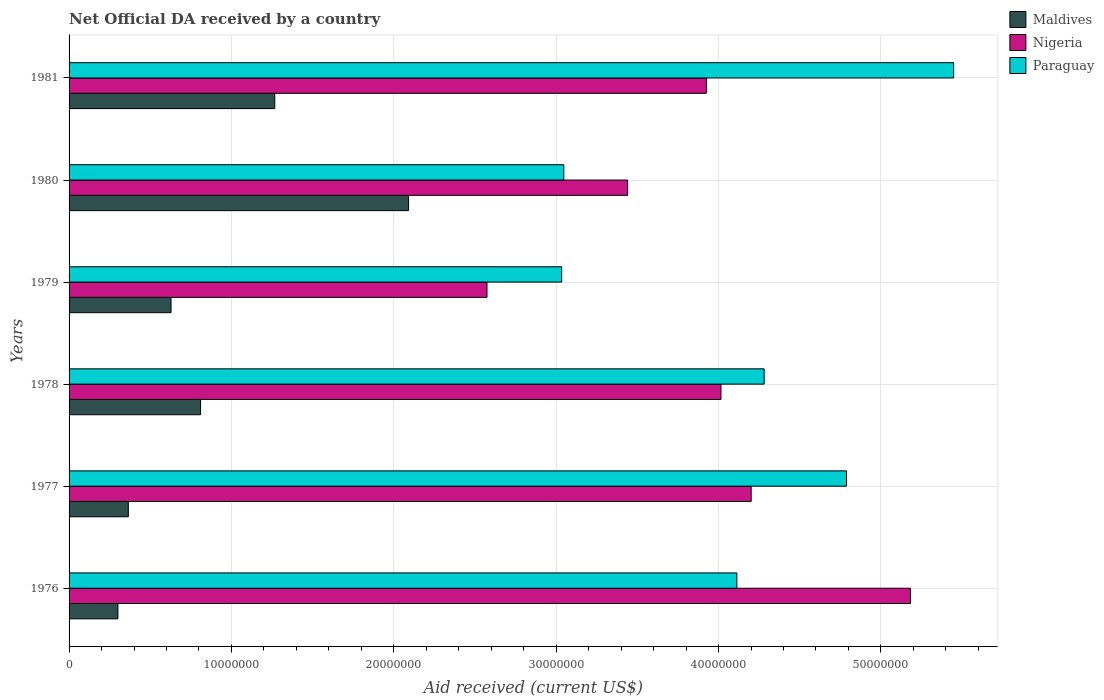How many groups of bars are there?
Ensure brevity in your answer.  6. Are the number of bars on each tick of the Y-axis equal?
Offer a very short reply. Yes. How many bars are there on the 1st tick from the top?
Keep it short and to the point. 3. How many bars are there on the 3rd tick from the bottom?
Keep it short and to the point. 3. What is the label of the 5th group of bars from the top?
Keep it short and to the point. 1977. What is the net official development assistance aid received in Paraguay in 1978?
Offer a terse response. 4.28e+07. Across all years, what is the maximum net official development assistance aid received in Maldives?
Offer a terse response. 2.09e+07. Across all years, what is the minimum net official development assistance aid received in Paraguay?
Provide a succinct answer. 3.03e+07. In which year was the net official development assistance aid received in Paraguay maximum?
Provide a short and direct response. 1981. In which year was the net official development assistance aid received in Maldives minimum?
Your answer should be compact. 1976. What is the total net official development assistance aid received in Maldives in the graph?
Your answer should be compact. 5.46e+07. What is the difference between the net official development assistance aid received in Paraguay in 1977 and that in 1978?
Offer a very short reply. 5.07e+06. What is the difference between the net official development assistance aid received in Maldives in 1978 and the net official development assistance aid received in Nigeria in 1976?
Give a very brief answer. -4.37e+07. What is the average net official development assistance aid received in Nigeria per year?
Provide a succinct answer. 3.89e+07. In the year 1976, what is the difference between the net official development assistance aid received in Maldives and net official development assistance aid received in Nigeria?
Provide a short and direct response. -4.88e+07. What is the ratio of the net official development assistance aid received in Paraguay in 1980 to that in 1981?
Give a very brief answer. 0.56. Is the net official development assistance aid received in Paraguay in 1977 less than that in 1979?
Your response must be concise. No. What is the difference between the highest and the second highest net official development assistance aid received in Paraguay?
Provide a short and direct response. 6.60e+06. What is the difference between the highest and the lowest net official development assistance aid received in Nigeria?
Ensure brevity in your answer.  2.61e+07. In how many years, is the net official development assistance aid received in Maldives greater than the average net official development assistance aid received in Maldives taken over all years?
Your response must be concise. 2. Is the sum of the net official development assistance aid received in Nigeria in 1976 and 1979 greater than the maximum net official development assistance aid received in Maldives across all years?
Provide a short and direct response. Yes. What does the 1st bar from the top in 1981 represents?
Offer a very short reply. Paraguay. What does the 2nd bar from the bottom in 1978 represents?
Ensure brevity in your answer.  Nigeria. Is it the case that in every year, the sum of the net official development assistance aid received in Paraguay and net official development assistance aid received in Maldives is greater than the net official development assistance aid received in Nigeria?
Offer a terse response. No. Are all the bars in the graph horizontal?
Give a very brief answer. Yes. How many years are there in the graph?
Give a very brief answer. 6. What is the difference between two consecutive major ticks on the X-axis?
Provide a short and direct response. 1.00e+07. Are the values on the major ticks of X-axis written in scientific E-notation?
Provide a short and direct response. No. Does the graph contain grids?
Your response must be concise. Yes. How many legend labels are there?
Ensure brevity in your answer.  3. How are the legend labels stacked?
Keep it short and to the point. Vertical. What is the title of the graph?
Provide a succinct answer. Net Official DA received by a country. What is the label or title of the X-axis?
Your answer should be compact. Aid received (current US$). What is the Aid received (current US$) of Maldives in 1976?
Your answer should be very brief. 3.01e+06. What is the Aid received (current US$) in Nigeria in 1976?
Make the answer very short. 5.18e+07. What is the Aid received (current US$) of Paraguay in 1976?
Offer a very short reply. 4.11e+07. What is the Aid received (current US$) in Maldives in 1977?
Offer a terse response. 3.65e+06. What is the Aid received (current US$) of Nigeria in 1977?
Your response must be concise. 4.20e+07. What is the Aid received (current US$) of Paraguay in 1977?
Offer a very short reply. 4.79e+07. What is the Aid received (current US$) of Maldives in 1978?
Your response must be concise. 8.10e+06. What is the Aid received (current US$) of Nigeria in 1978?
Make the answer very short. 4.02e+07. What is the Aid received (current US$) in Paraguay in 1978?
Your answer should be compact. 4.28e+07. What is the Aid received (current US$) in Maldives in 1979?
Keep it short and to the point. 6.28e+06. What is the Aid received (current US$) of Nigeria in 1979?
Provide a succinct answer. 2.57e+07. What is the Aid received (current US$) in Paraguay in 1979?
Keep it short and to the point. 3.03e+07. What is the Aid received (current US$) of Maldives in 1980?
Make the answer very short. 2.09e+07. What is the Aid received (current US$) of Nigeria in 1980?
Your response must be concise. 3.44e+07. What is the Aid received (current US$) in Paraguay in 1980?
Your answer should be compact. 3.05e+07. What is the Aid received (current US$) of Maldives in 1981?
Keep it short and to the point. 1.27e+07. What is the Aid received (current US$) of Nigeria in 1981?
Make the answer very short. 3.92e+07. What is the Aid received (current US$) of Paraguay in 1981?
Your response must be concise. 5.45e+07. Across all years, what is the maximum Aid received (current US$) in Maldives?
Ensure brevity in your answer.  2.09e+07. Across all years, what is the maximum Aid received (current US$) of Nigeria?
Provide a short and direct response. 5.18e+07. Across all years, what is the maximum Aid received (current US$) of Paraguay?
Give a very brief answer. 5.45e+07. Across all years, what is the minimum Aid received (current US$) in Maldives?
Provide a succinct answer. 3.01e+06. Across all years, what is the minimum Aid received (current US$) in Nigeria?
Offer a very short reply. 2.57e+07. Across all years, what is the minimum Aid received (current US$) in Paraguay?
Provide a short and direct response. 3.03e+07. What is the total Aid received (current US$) of Maldives in the graph?
Give a very brief answer. 5.46e+07. What is the total Aid received (current US$) in Nigeria in the graph?
Provide a succinct answer. 2.33e+08. What is the total Aid received (current US$) of Paraguay in the graph?
Your response must be concise. 2.47e+08. What is the difference between the Aid received (current US$) of Maldives in 1976 and that in 1977?
Offer a very short reply. -6.40e+05. What is the difference between the Aid received (current US$) of Nigeria in 1976 and that in 1977?
Offer a very short reply. 9.81e+06. What is the difference between the Aid received (current US$) in Paraguay in 1976 and that in 1977?
Your response must be concise. -6.75e+06. What is the difference between the Aid received (current US$) of Maldives in 1976 and that in 1978?
Your answer should be very brief. -5.09e+06. What is the difference between the Aid received (current US$) of Nigeria in 1976 and that in 1978?
Your response must be concise. 1.17e+07. What is the difference between the Aid received (current US$) of Paraguay in 1976 and that in 1978?
Ensure brevity in your answer.  -1.68e+06. What is the difference between the Aid received (current US$) in Maldives in 1976 and that in 1979?
Give a very brief answer. -3.27e+06. What is the difference between the Aid received (current US$) in Nigeria in 1976 and that in 1979?
Offer a terse response. 2.61e+07. What is the difference between the Aid received (current US$) in Paraguay in 1976 and that in 1979?
Give a very brief answer. 1.08e+07. What is the difference between the Aid received (current US$) of Maldives in 1976 and that in 1980?
Offer a very short reply. -1.79e+07. What is the difference between the Aid received (current US$) of Nigeria in 1976 and that in 1980?
Keep it short and to the point. 1.74e+07. What is the difference between the Aid received (current US$) of Paraguay in 1976 and that in 1980?
Provide a succinct answer. 1.07e+07. What is the difference between the Aid received (current US$) in Maldives in 1976 and that in 1981?
Give a very brief answer. -9.66e+06. What is the difference between the Aid received (current US$) of Nigeria in 1976 and that in 1981?
Give a very brief answer. 1.26e+07. What is the difference between the Aid received (current US$) in Paraguay in 1976 and that in 1981?
Keep it short and to the point. -1.34e+07. What is the difference between the Aid received (current US$) of Maldives in 1977 and that in 1978?
Provide a short and direct response. -4.45e+06. What is the difference between the Aid received (current US$) of Nigeria in 1977 and that in 1978?
Offer a terse response. 1.86e+06. What is the difference between the Aid received (current US$) of Paraguay in 1977 and that in 1978?
Provide a short and direct response. 5.07e+06. What is the difference between the Aid received (current US$) in Maldives in 1977 and that in 1979?
Your response must be concise. -2.63e+06. What is the difference between the Aid received (current US$) in Nigeria in 1977 and that in 1979?
Provide a short and direct response. 1.63e+07. What is the difference between the Aid received (current US$) of Paraguay in 1977 and that in 1979?
Ensure brevity in your answer.  1.75e+07. What is the difference between the Aid received (current US$) of Maldives in 1977 and that in 1980?
Give a very brief answer. -1.73e+07. What is the difference between the Aid received (current US$) in Nigeria in 1977 and that in 1980?
Your answer should be compact. 7.61e+06. What is the difference between the Aid received (current US$) of Paraguay in 1977 and that in 1980?
Give a very brief answer. 1.74e+07. What is the difference between the Aid received (current US$) of Maldives in 1977 and that in 1981?
Offer a very short reply. -9.02e+06. What is the difference between the Aid received (current US$) of Nigeria in 1977 and that in 1981?
Offer a very short reply. 2.76e+06. What is the difference between the Aid received (current US$) in Paraguay in 1977 and that in 1981?
Your answer should be very brief. -6.60e+06. What is the difference between the Aid received (current US$) of Maldives in 1978 and that in 1979?
Provide a short and direct response. 1.82e+06. What is the difference between the Aid received (current US$) of Nigeria in 1978 and that in 1979?
Your answer should be compact. 1.44e+07. What is the difference between the Aid received (current US$) of Paraguay in 1978 and that in 1979?
Offer a terse response. 1.25e+07. What is the difference between the Aid received (current US$) of Maldives in 1978 and that in 1980?
Provide a short and direct response. -1.28e+07. What is the difference between the Aid received (current US$) of Nigeria in 1978 and that in 1980?
Offer a terse response. 5.75e+06. What is the difference between the Aid received (current US$) of Paraguay in 1978 and that in 1980?
Keep it short and to the point. 1.23e+07. What is the difference between the Aid received (current US$) in Maldives in 1978 and that in 1981?
Make the answer very short. -4.57e+06. What is the difference between the Aid received (current US$) of Nigeria in 1978 and that in 1981?
Ensure brevity in your answer.  9.00e+05. What is the difference between the Aid received (current US$) of Paraguay in 1978 and that in 1981?
Keep it short and to the point. -1.17e+07. What is the difference between the Aid received (current US$) of Maldives in 1979 and that in 1980?
Offer a very short reply. -1.46e+07. What is the difference between the Aid received (current US$) in Nigeria in 1979 and that in 1980?
Offer a very short reply. -8.66e+06. What is the difference between the Aid received (current US$) in Maldives in 1979 and that in 1981?
Provide a succinct answer. -6.39e+06. What is the difference between the Aid received (current US$) of Nigeria in 1979 and that in 1981?
Ensure brevity in your answer.  -1.35e+07. What is the difference between the Aid received (current US$) of Paraguay in 1979 and that in 1981?
Provide a succinct answer. -2.41e+07. What is the difference between the Aid received (current US$) of Maldives in 1980 and that in 1981?
Make the answer very short. 8.24e+06. What is the difference between the Aid received (current US$) in Nigeria in 1980 and that in 1981?
Make the answer very short. -4.85e+06. What is the difference between the Aid received (current US$) of Paraguay in 1980 and that in 1981?
Keep it short and to the point. -2.40e+07. What is the difference between the Aid received (current US$) in Maldives in 1976 and the Aid received (current US$) in Nigeria in 1977?
Offer a terse response. -3.90e+07. What is the difference between the Aid received (current US$) in Maldives in 1976 and the Aid received (current US$) in Paraguay in 1977?
Keep it short and to the point. -4.49e+07. What is the difference between the Aid received (current US$) of Nigeria in 1976 and the Aid received (current US$) of Paraguay in 1977?
Give a very brief answer. 3.94e+06. What is the difference between the Aid received (current US$) in Maldives in 1976 and the Aid received (current US$) in Nigeria in 1978?
Your response must be concise. -3.71e+07. What is the difference between the Aid received (current US$) of Maldives in 1976 and the Aid received (current US$) of Paraguay in 1978?
Offer a very short reply. -3.98e+07. What is the difference between the Aid received (current US$) of Nigeria in 1976 and the Aid received (current US$) of Paraguay in 1978?
Keep it short and to the point. 9.01e+06. What is the difference between the Aid received (current US$) of Maldives in 1976 and the Aid received (current US$) of Nigeria in 1979?
Give a very brief answer. -2.27e+07. What is the difference between the Aid received (current US$) in Maldives in 1976 and the Aid received (current US$) in Paraguay in 1979?
Offer a very short reply. -2.73e+07. What is the difference between the Aid received (current US$) of Nigeria in 1976 and the Aid received (current US$) of Paraguay in 1979?
Provide a succinct answer. 2.15e+07. What is the difference between the Aid received (current US$) of Maldives in 1976 and the Aid received (current US$) of Nigeria in 1980?
Ensure brevity in your answer.  -3.14e+07. What is the difference between the Aid received (current US$) of Maldives in 1976 and the Aid received (current US$) of Paraguay in 1980?
Your response must be concise. -2.75e+07. What is the difference between the Aid received (current US$) in Nigeria in 1976 and the Aid received (current US$) in Paraguay in 1980?
Ensure brevity in your answer.  2.14e+07. What is the difference between the Aid received (current US$) of Maldives in 1976 and the Aid received (current US$) of Nigeria in 1981?
Your response must be concise. -3.62e+07. What is the difference between the Aid received (current US$) of Maldives in 1976 and the Aid received (current US$) of Paraguay in 1981?
Keep it short and to the point. -5.15e+07. What is the difference between the Aid received (current US$) of Nigeria in 1976 and the Aid received (current US$) of Paraguay in 1981?
Your response must be concise. -2.66e+06. What is the difference between the Aid received (current US$) of Maldives in 1977 and the Aid received (current US$) of Nigeria in 1978?
Give a very brief answer. -3.65e+07. What is the difference between the Aid received (current US$) of Maldives in 1977 and the Aid received (current US$) of Paraguay in 1978?
Your answer should be very brief. -3.92e+07. What is the difference between the Aid received (current US$) of Nigeria in 1977 and the Aid received (current US$) of Paraguay in 1978?
Your answer should be very brief. -8.00e+05. What is the difference between the Aid received (current US$) of Maldives in 1977 and the Aid received (current US$) of Nigeria in 1979?
Keep it short and to the point. -2.21e+07. What is the difference between the Aid received (current US$) of Maldives in 1977 and the Aid received (current US$) of Paraguay in 1979?
Offer a terse response. -2.67e+07. What is the difference between the Aid received (current US$) in Nigeria in 1977 and the Aid received (current US$) in Paraguay in 1979?
Ensure brevity in your answer.  1.17e+07. What is the difference between the Aid received (current US$) of Maldives in 1977 and the Aid received (current US$) of Nigeria in 1980?
Offer a terse response. -3.08e+07. What is the difference between the Aid received (current US$) of Maldives in 1977 and the Aid received (current US$) of Paraguay in 1980?
Offer a terse response. -2.68e+07. What is the difference between the Aid received (current US$) in Nigeria in 1977 and the Aid received (current US$) in Paraguay in 1980?
Provide a succinct answer. 1.15e+07. What is the difference between the Aid received (current US$) in Maldives in 1977 and the Aid received (current US$) in Nigeria in 1981?
Your answer should be compact. -3.56e+07. What is the difference between the Aid received (current US$) of Maldives in 1977 and the Aid received (current US$) of Paraguay in 1981?
Keep it short and to the point. -5.08e+07. What is the difference between the Aid received (current US$) in Nigeria in 1977 and the Aid received (current US$) in Paraguay in 1981?
Make the answer very short. -1.25e+07. What is the difference between the Aid received (current US$) of Maldives in 1978 and the Aid received (current US$) of Nigeria in 1979?
Keep it short and to the point. -1.76e+07. What is the difference between the Aid received (current US$) of Maldives in 1978 and the Aid received (current US$) of Paraguay in 1979?
Offer a very short reply. -2.22e+07. What is the difference between the Aid received (current US$) of Nigeria in 1978 and the Aid received (current US$) of Paraguay in 1979?
Provide a succinct answer. 9.81e+06. What is the difference between the Aid received (current US$) in Maldives in 1978 and the Aid received (current US$) in Nigeria in 1980?
Ensure brevity in your answer.  -2.63e+07. What is the difference between the Aid received (current US$) of Maldives in 1978 and the Aid received (current US$) of Paraguay in 1980?
Give a very brief answer. -2.24e+07. What is the difference between the Aid received (current US$) of Nigeria in 1978 and the Aid received (current US$) of Paraguay in 1980?
Offer a very short reply. 9.68e+06. What is the difference between the Aid received (current US$) of Maldives in 1978 and the Aid received (current US$) of Nigeria in 1981?
Ensure brevity in your answer.  -3.12e+07. What is the difference between the Aid received (current US$) in Maldives in 1978 and the Aid received (current US$) in Paraguay in 1981?
Ensure brevity in your answer.  -4.64e+07. What is the difference between the Aid received (current US$) in Nigeria in 1978 and the Aid received (current US$) in Paraguay in 1981?
Keep it short and to the point. -1.43e+07. What is the difference between the Aid received (current US$) of Maldives in 1979 and the Aid received (current US$) of Nigeria in 1980?
Provide a short and direct response. -2.81e+07. What is the difference between the Aid received (current US$) of Maldives in 1979 and the Aid received (current US$) of Paraguay in 1980?
Keep it short and to the point. -2.42e+07. What is the difference between the Aid received (current US$) in Nigeria in 1979 and the Aid received (current US$) in Paraguay in 1980?
Offer a terse response. -4.73e+06. What is the difference between the Aid received (current US$) of Maldives in 1979 and the Aid received (current US$) of Nigeria in 1981?
Provide a succinct answer. -3.30e+07. What is the difference between the Aid received (current US$) of Maldives in 1979 and the Aid received (current US$) of Paraguay in 1981?
Offer a terse response. -4.82e+07. What is the difference between the Aid received (current US$) in Nigeria in 1979 and the Aid received (current US$) in Paraguay in 1981?
Offer a very short reply. -2.87e+07. What is the difference between the Aid received (current US$) in Maldives in 1980 and the Aid received (current US$) in Nigeria in 1981?
Your answer should be compact. -1.83e+07. What is the difference between the Aid received (current US$) of Maldives in 1980 and the Aid received (current US$) of Paraguay in 1981?
Your response must be concise. -3.36e+07. What is the difference between the Aid received (current US$) of Nigeria in 1980 and the Aid received (current US$) of Paraguay in 1981?
Make the answer very short. -2.01e+07. What is the average Aid received (current US$) of Maldives per year?
Ensure brevity in your answer.  9.10e+06. What is the average Aid received (current US$) in Nigeria per year?
Make the answer very short. 3.89e+07. What is the average Aid received (current US$) in Paraguay per year?
Your answer should be very brief. 4.12e+07. In the year 1976, what is the difference between the Aid received (current US$) in Maldives and Aid received (current US$) in Nigeria?
Your response must be concise. -4.88e+07. In the year 1976, what is the difference between the Aid received (current US$) of Maldives and Aid received (current US$) of Paraguay?
Your answer should be very brief. -3.81e+07. In the year 1976, what is the difference between the Aid received (current US$) of Nigeria and Aid received (current US$) of Paraguay?
Make the answer very short. 1.07e+07. In the year 1977, what is the difference between the Aid received (current US$) of Maldives and Aid received (current US$) of Nigeria?
Provide a short and direct response. -3.84e+07. In the year 1977, what is the difference between the Aid received (current US$) of Maldives and Aid received (current US$) of Paraguay?
Provide a short and direct response. -4.42e+07. In the year 1977, what is the difference between the Aid received (current US$) of Nigeria and Aid received (current US$) of Paraguay?
Offer a terse response. -5.87e+06. In the year 1978, what is the difference between the Aid received (current US$) in Maldives and Aid received (current US$) in Nigeria?
Your response must be concise. -3.20e+07. In the year 1978, what is the difference between the Aid received (current US$) in Maldives and Aid received (current US$) in Paraguay?
Keep it short and to the point. -3.47e+07. In the year 1978, what is the difference between the Aid received (current US$) in Nigeria and Aid received (current US$) in Paraguay?
Offer a very short reply. -2.66e+06. In the year 1979, what is the difference between the Aid received (current US$) of Maldives and Aid received (current US$) of Nigeria?
Offer a very short reply. -1.95e+07. In the year 1979, what is the difference between the Aid received (current US$) of Maldives and Aid received (current US$) of Paraguay?
Provide a succinct answer. -2.41e+07. In the year 1979, what is the difference between the Aid received (current US$) of Nigeria and Aid received (current US$) of Paraguay?
Your response must be concise. -4.60e+06. In the year 1980, what is the difference between the Aid received (current US$) in Maldives and Aid received (current US$) in Nigeria?
Your response must be concise. -1.35e+07. In the year 1980, what is the difference between the Aid received (current US$) in Maldives and Aid received (current US$) in Paraguay?
Your answer should be very brief. -9.56e+06. In the year 1980, what is the difference between the Aid received (current US$) of Nigeria and Aid received (current US$) of Paraguay?
Provide a short and direct response. 3.93e+06. In the year 1981, what is the difference between the Aid received (current US$) in Maldives and Aid received (current US$) in Nigeria?
Offer a terse response. -2.66e+07. In the year 1981, what is the difference between the Aid received (current US$) of Maldives and Aid received (current US$) of Paraguay?
Your answer should be very brief. -4.18e+07. In the year 1981, what is the difference between the Aid received (current US$) of Nigeria and Aid received (current US$) of Paraguay?
Your answer should be very brief. -1.52e+07. What is the ratio of the Aid received (current US$) in Maldives in 1976 to that in 1977?
Offer a very short reply. 0.82. What is the ratio of the Aid received (current US$) of Nigeria in 1976 to that in 1977?
Your answer should be compact. 1.23. What is the ratio of the Aid received (current US$) of Paraguay in 1976 to that in 1977?
Provide a succinct answer. 0.86. What is the ratio of the Aid received (current US$) in Maldives in 1976 to that in 1978?
Give a very brief answer. 0.37. What is the ratio of the Aid received (current US$) in Nigeria in 1976 to that in 1978?
Ensure brevity in your answer.  1.29. What is the ratio of the Aid received (current US$) in Paraguay in 1976 to that in 1978?
Offer a very short reply. 0.96. What is the ratio of the Aid received (current US$) in Maldives in 1976 to that in 1979?
Offer a terse response. 0.48. What is the ratio of the Aid received (current US$) of Nigeria in 1976 to that in 1979?
Your answer should be very brief. 2.01. What is the ratio of the Aid received (current US$) in Paraguay in 1976 to that in 1979?
Give a very brief answer. 1.36. What is the ratio of the Aid received (current US$) in Maldives in 1976 to that in 1980?
Provide a succinct answer. 0.14. What is the ratio of the Aid received (current US$) of Nigeria in 1976 to that in 1980?
Your answer should be very brief. 1.51. What is the ratio of the Aid received (current US$) in Paraguay in 1976 to that in 1980?
Give a very brief answer. 1.35. What is the ratio of the Aid received (current US$) of Maldives in 1976 to that in 1981?
Ensure brevity in your answer.  0.24. What is the ratio of the Aid received (current US$) of Nigeria in 1976 to that in 1981?
Your answer should be very brief. 1.32. What is the ratio of the Aid received (current US$) of Paraguay in 1976 to that in 1981?
Ensure brevity in your answer.  0.76. What is the ratio of the Aid received (current US$) in Maldives in 1977 to that in 1978?
Provide a succinct answer. 0.45. What is the ratio of the Aid received (current US$) in Nigeria in 1977 to that in 1978?
Provide a short and direct response. 1.05. What is the ratio of the Aid received (current US$) of Paraguay in 1977 to that in 1978?
Offer a very short reply. 1.12. What is the ratio of the Aid received (current US$) of Maldives in 1977 to that in 1979?
Ensure brevity in your answer.  0.58. What is the ratio of the Aid received (current US$) in Nigeria in 1977 to that in 1979?
Ensure brevity in your answer.  1.63. What is the ratio of the Aid received (current US$) of Paraguay in 1977 to that in 1979?
Make the answer very short. 1.58. What is the ratio of the Aid received (current US$) of Maldives in 1977 to that in 1980?
Make the answer very short. 0.17. What is the ratio of the Aid received (current US$) in Nigeria in 1977 to that in 1980?
Keep it short and to the point. 1.22. What is the ratio of the Aid received (current US$) of Paraguay in 1977 to that in 1980?
Your answer should be very brief. 1.57. What is the ratio of the Aid received (current US$) of Maldives in 1977 to that in 1981?
Keep it short and to the point. 0.29. What is the ratio of the Aid received (current US$) of Nigeria in 1977 to that in 1981?
Provide a succinct answer. 1.07. What is the ratio of the Aid received (current US$) of Paraguay in 1977 to that in 1981?
Ensure brevity in your answer.  0.88. What is the ratio of the Aid received (current US$) of Maldives in 1978 to that in 1979?
Make the answer very short. 1.29. What is the ratio of the Aid received (current US$) in Nigeria in 1978 to that in 1979?
Offer a terse response. 1.56. What is the ratio of the Aid received (current US$) of Paraguay in 1978 to that in 1979?
Offer a very short reply. 1.41. What is the ratio of the Aid received (current US$) in Maldives in 1978 to that in 1980?
Make the answer very short. 0.39. What is the ratio of the Aid received (current US$) in Nigeria in 1978 to that in 1980?
Give a very brief answer. 1.17. What is the ratio of the Aid received (current US$) of Paraguay in 1978 to that in 1980?
Your answer should be compact. 1.41. What is the ratio of the Aid received (current US$) of Maldives in 1978 to that in 1981?
Your answer should be compact. 0.64. What is the ratio of the Aid received (current US$) of Nigeria in 1978 to that in 1981?
Ensure brevity in your answer.  1.02. What is the ratio of the Aid received (current US$) in Paraguay in 1978 to that in 1981?
Offer a terse response. 0.79. What is the ratio of the Aid received (current US$) in Maldives in 1979 to that in 1980?
Your answer should be very brief. 0.3. What is the ratio of the Aid received (current US$) in Nigeria in 1979 to that in 1980?
Keep it short and to the point. 0.75. What is the ratio of the Aid received (current US$) of Paraguay in 1979 to that in 1980?
Give a very brief answer. 1. What is the ratio of the Aid received (current US$) in Maldives in 1979 to that in 1981?
Give a very brief answer. 0.5. What is the ratio of the Aid received (current US$) of Nigeria in 1979 to that in 1981?
Offer a terse response. 0.66. What is the ratio of the Aid received (current US$) in Paraguay in 1979 to that in 1981?
Ensure brevity in your answer.  0.56. What is the ratio of the Aid received (current US$) of Maldives in 1980 to that in 1981?
Provide a succinct answer. 1.65. What is the ratio of the Aid received (current US$) in Nigeria in 1980 to that in 1981?
Offer a terse response. 0.88. What is the ratio of the Aid received (current US$) of Paraguay in 1980 to that in 1981?
Give a very brief answer. 0.56. What is the difference between the highest and the second highest Aid received (current US$) in Maldives?
Your response must be concise. 8.24e+06. What is the difference between the highest and the second highest Aid received (current US$) of Nigeria?
Provide a short and direct response. 9.81e+06. What is the difference between the highest and the second highest Aid received (current US$) of Paraguay?
Make the answer very short. 6.60e+06. What is the difference between the highest and the lowest Aid received (current US$) in Maldives?
Your answer should be very brief. 1.79e+07. What is the difference between the highest and the lowest Aid received (current US$) of Nigeria?
Provide a succinct answer. 2.61e+07. What is the difference between the highest and the lowest Aid received (current US$) of Paraguay?
Make the answer very short. 2.41e+07. 